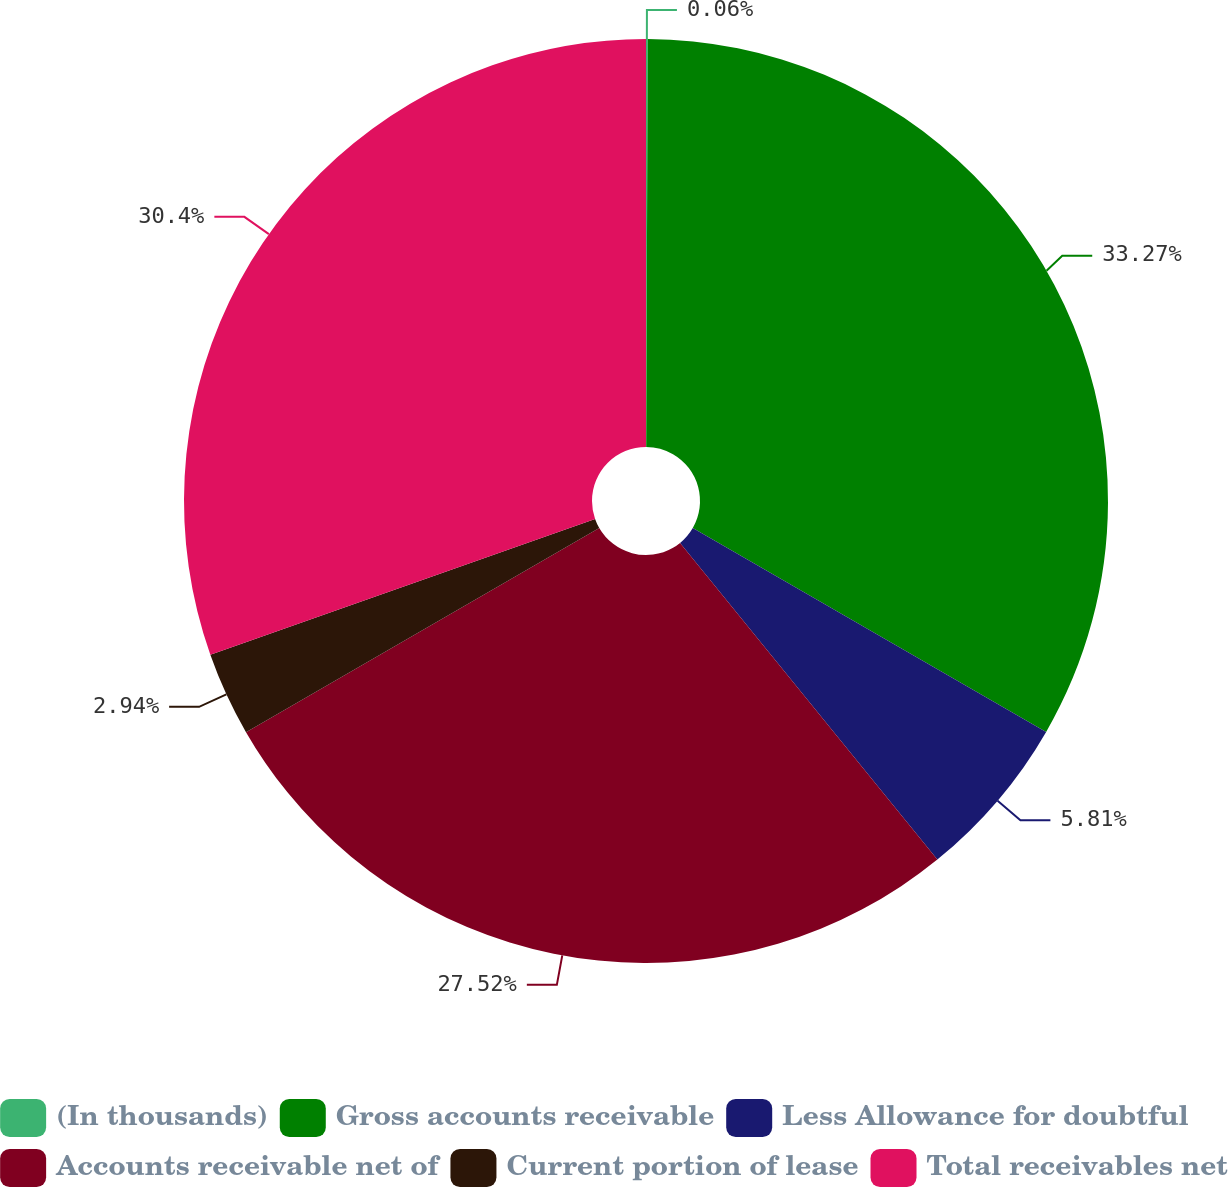Convert chart to OTSL. <chart><loc_0><loc_0><loc_500><loc_500><pie_chart><fcel>(In thousands)<fcel>Gross accounts receivable<fcel>Less Allowance for doubtful<fcel>Accounts receivable net of<fcel>Current portion of lease<fcel>Total receivables net<nl><fcel>0.06%<fcel>33.27%<fcel>5.81%<fcel>27.52%<fcel>2.94%<fcel>30.4%<nl></chart> 